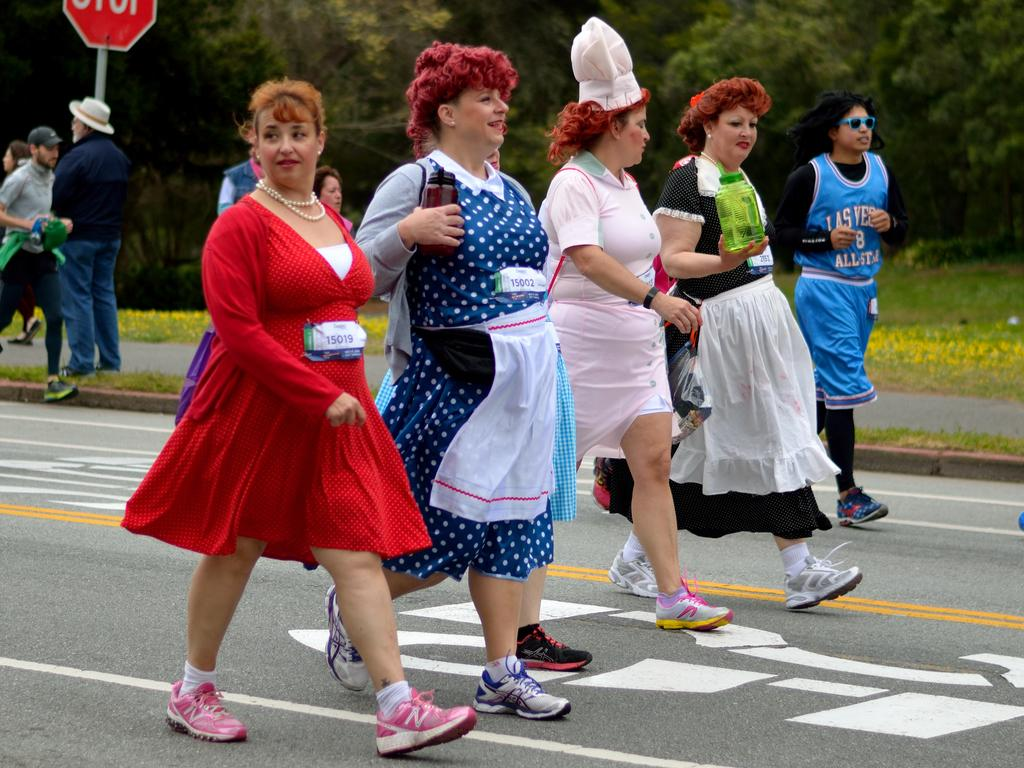What are the people in the image doing? The people in the image are walking on the road. What can be seen near the road in the image? There is a sign board in the image, and a man is standing near it. What type of vegetation is present in the image? There are trees in the image, and there is grass on the ground. What color is the mint growing on the ground in the image? There is no mint growing on the ground in the image; it only shows grass. How many eggs can be seen in the image? There are no eggs present in the image. 